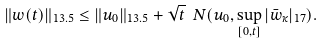Convert formula to latex. <formula><loc_0><loc_0><loc_500><loc_500>\| w ( t ) \| _ { 1 3 . 5 } \leq \| u _ { 0 } \| _ { 1 3 . 5 } + \sqrt { t } \ N ( u _ { 0 } , \sup _ { [ 0 , t ] } | \bar { w } _ { \kappa } | _ { 1 7 } ) .</formula> 